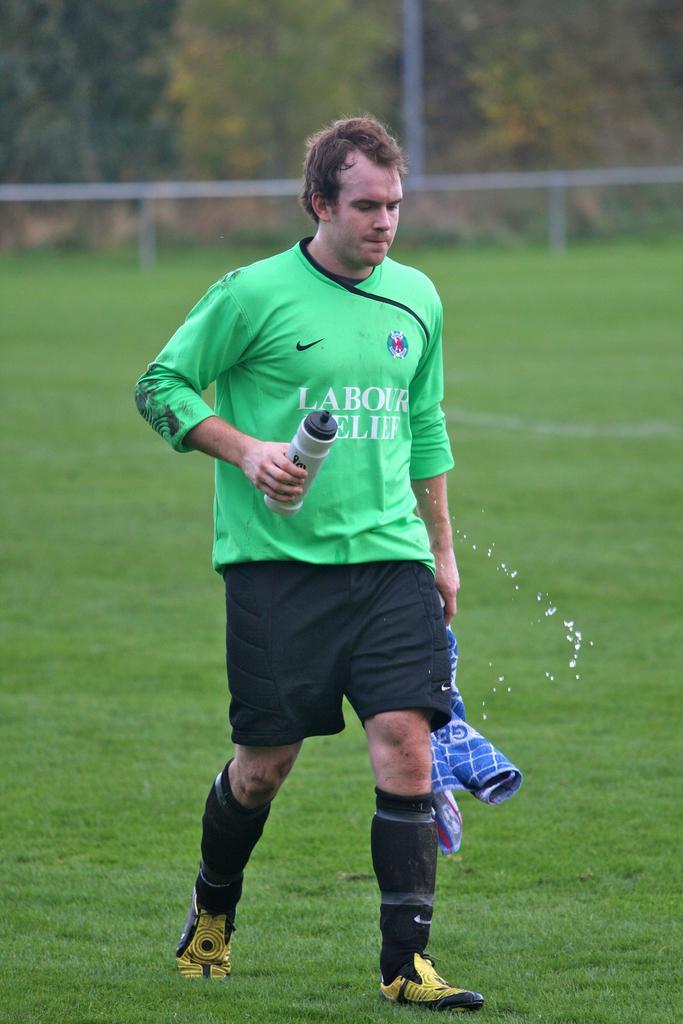How would you summarize this image in a sentence or two? In this image we can see a person wearing a dress is holding a bottle in his hand and a cloth in the other hand is standing on the grass field. In the background, we can see railing, pole and a group of trees. 